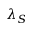Convert formula to latex. <formula><loc_0><loc_0><loc_500><loc_500>\lambda _ { S }</formula> 